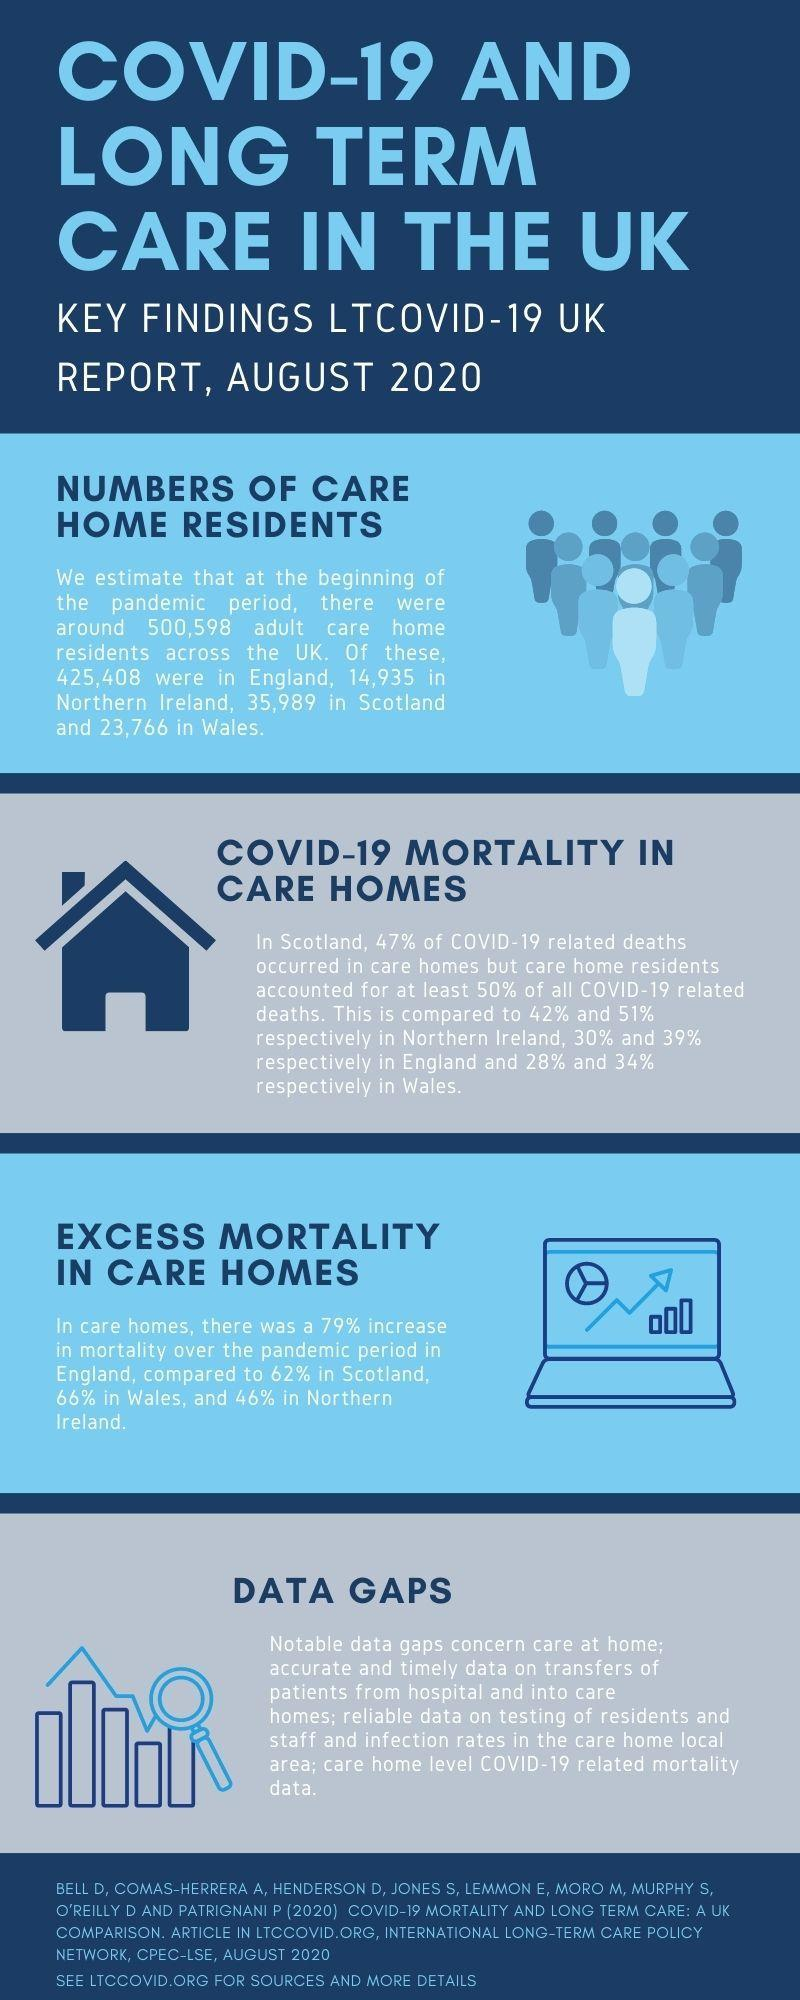What was the percentage increase in mortality in England's care homes?
Answer the question with a short phrase. 79% Care home residents accounted for how much percent of deaths in Northern Ireland? 51% 